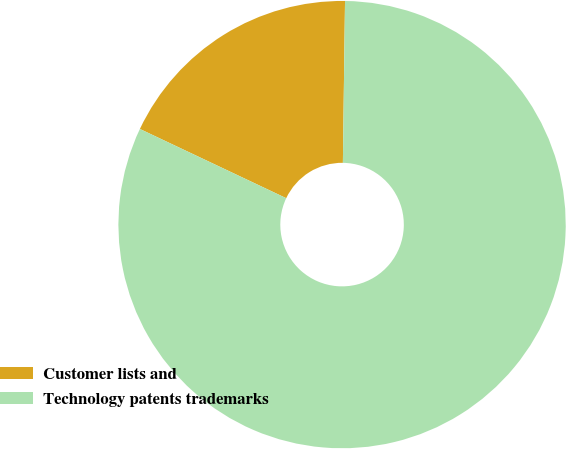Convert chart to OTSL. <chart><loc_0><loc_0><loc_500><loc_500><pie_chart><fcel>Customer lists and<fcel>Technology patents trademarks<nl><fcel>18.18%<fcel>81.82%<nl></chart> 